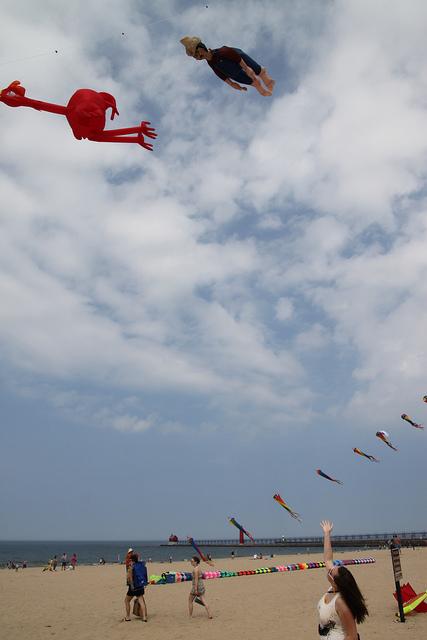What color is the largest kite?
Answer briefly. Red. How many kites are flying?
Be succinct. 2. What is in the air?
Keep it brief. Kites. Do the kites look like humans?
Answer briefly. No. Where are the people flying the kites?
Short answer required. Beach. 